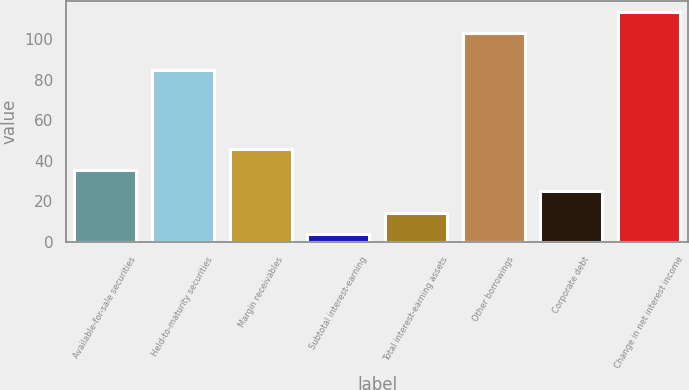<chart> <loc_0><loc_0><loc_500><loc_500><bar_chart><fcel>Available-for-sale securities<fcel>Held-to-maturity securities<fcel>Margin receivables<fcel>Subtotal interest-earning<fcel>Total interest-earning assets<fcel>Other borrowings<fcel>Corporate debt<fcel>Change in net interest income<nl><fcel>35.5<fcel>85<fcel>46<fcel>4<fcel>14.5<fcel>103<fcel>25<fcel>113.5<nl></chart> 